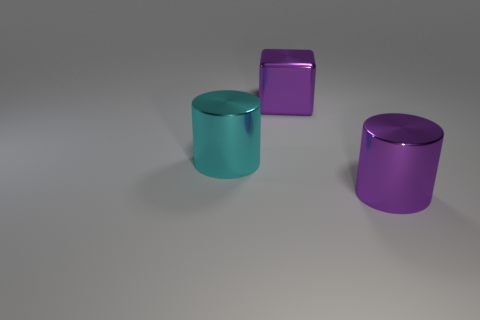Add 1 cyan shiny cylinders. How many objects exist? 4 Subtract all cylinders. How many objects are left? 1 Add 1 large cyan metallic objects. How many large cyan metallic objects exist? 2 Subtract 0 cyan balls. How many objects are left? 3 Subtract all cyan metallic things. Subtract all purple metallic cylinders. How many objects are left? 1 Add 1 large purple shiny objects. How many large purple shiny objects are left? 3 